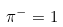Convert formula to latex. <formula><loc_0><loc_0><loc_500><loc_500>\pi ^ { - } = 1</formula> 